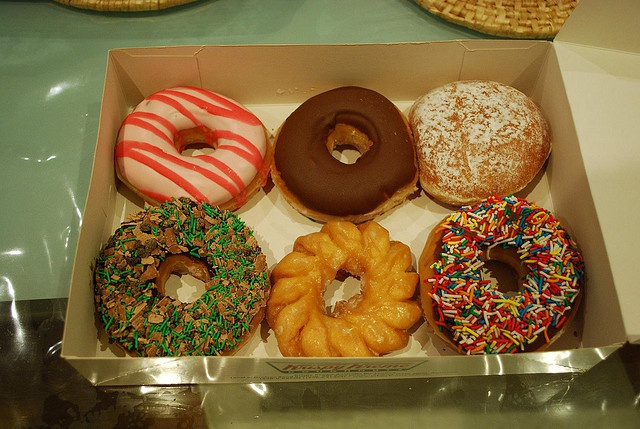Describe the objects in this image and their specific colors. I can see dining table in olive, tan, maroon, and black tones, donut in black, olive, and maroon tones, donut in black, maroon, and brown tones, donut in black, red, orange, and maroon tones, and donut in black, maroon, brown, and tan tones in this image. 